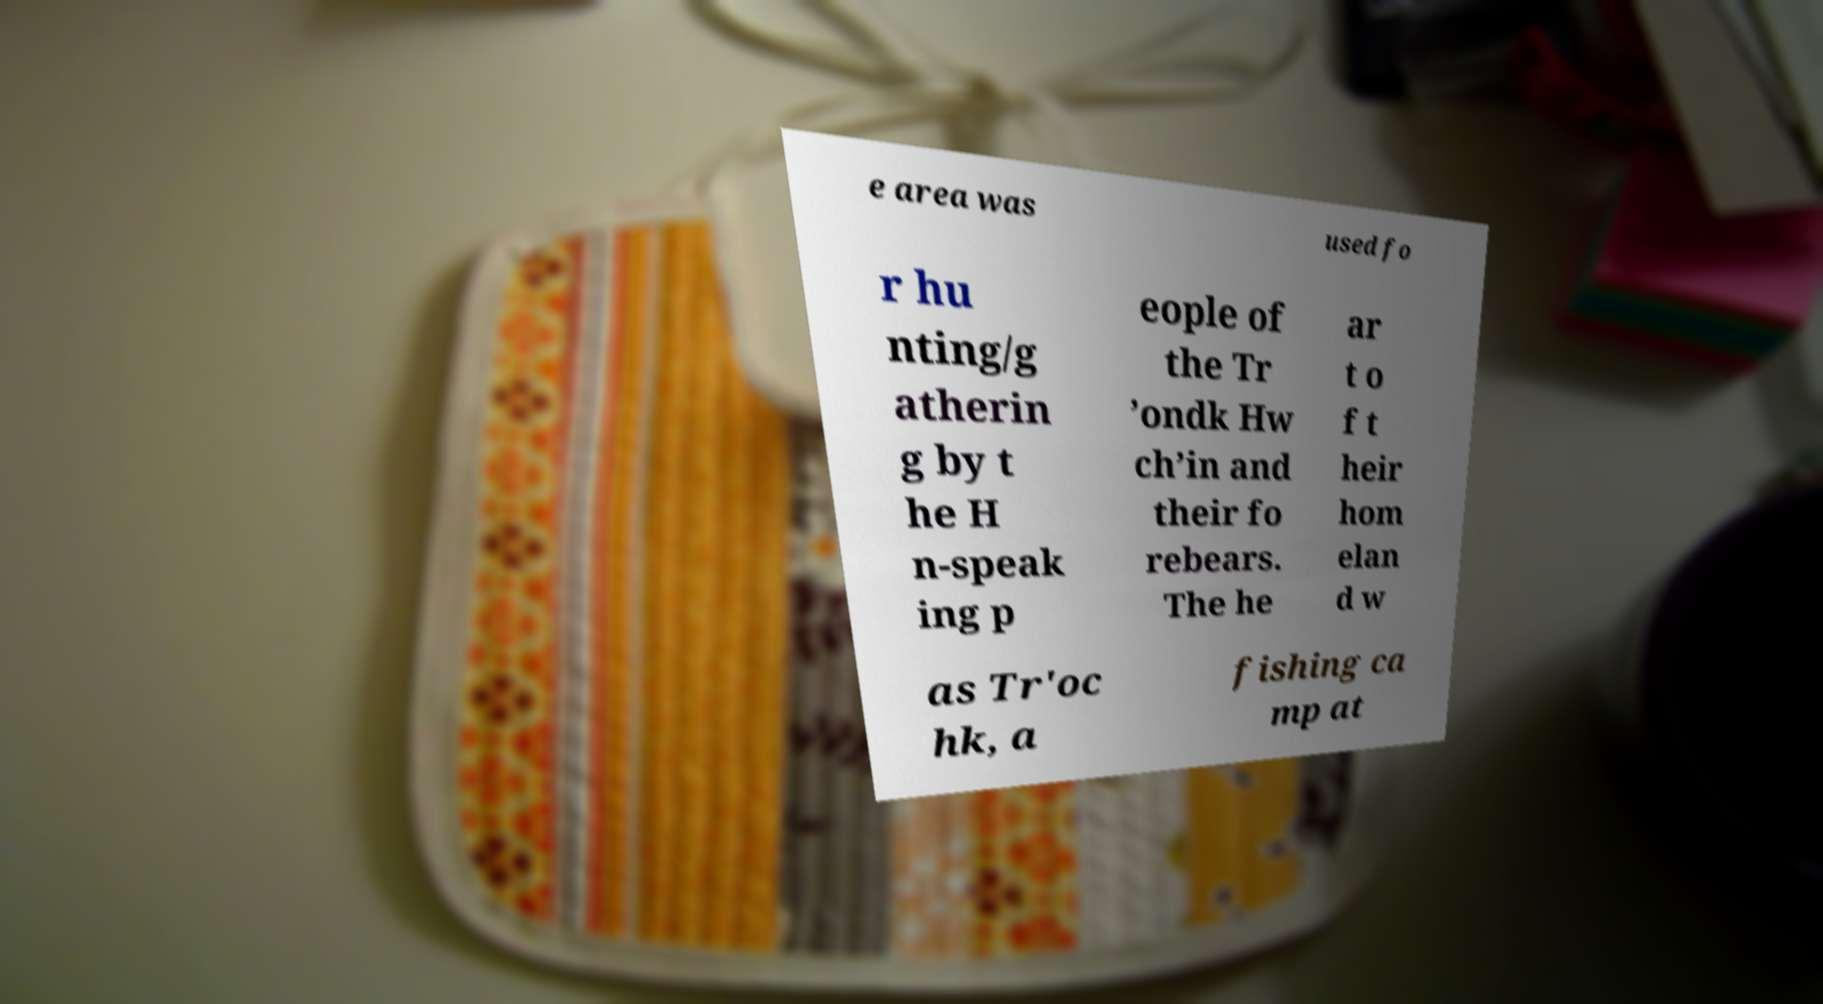Could you assist in decoding the text presented in this image and type it out clearly? e area was used fo r hu nting/g atherin g by t he H n-speak ing p eople of the Tr ’ondk Hw ch’in and their fo rebears. The he ar t o f t heir hom elan d w as Tr'oc hk, a fishing ca mp at 